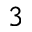<formula> <loc_0><loc_0><loc_500><loc_500>^ { 3 }</formula> 